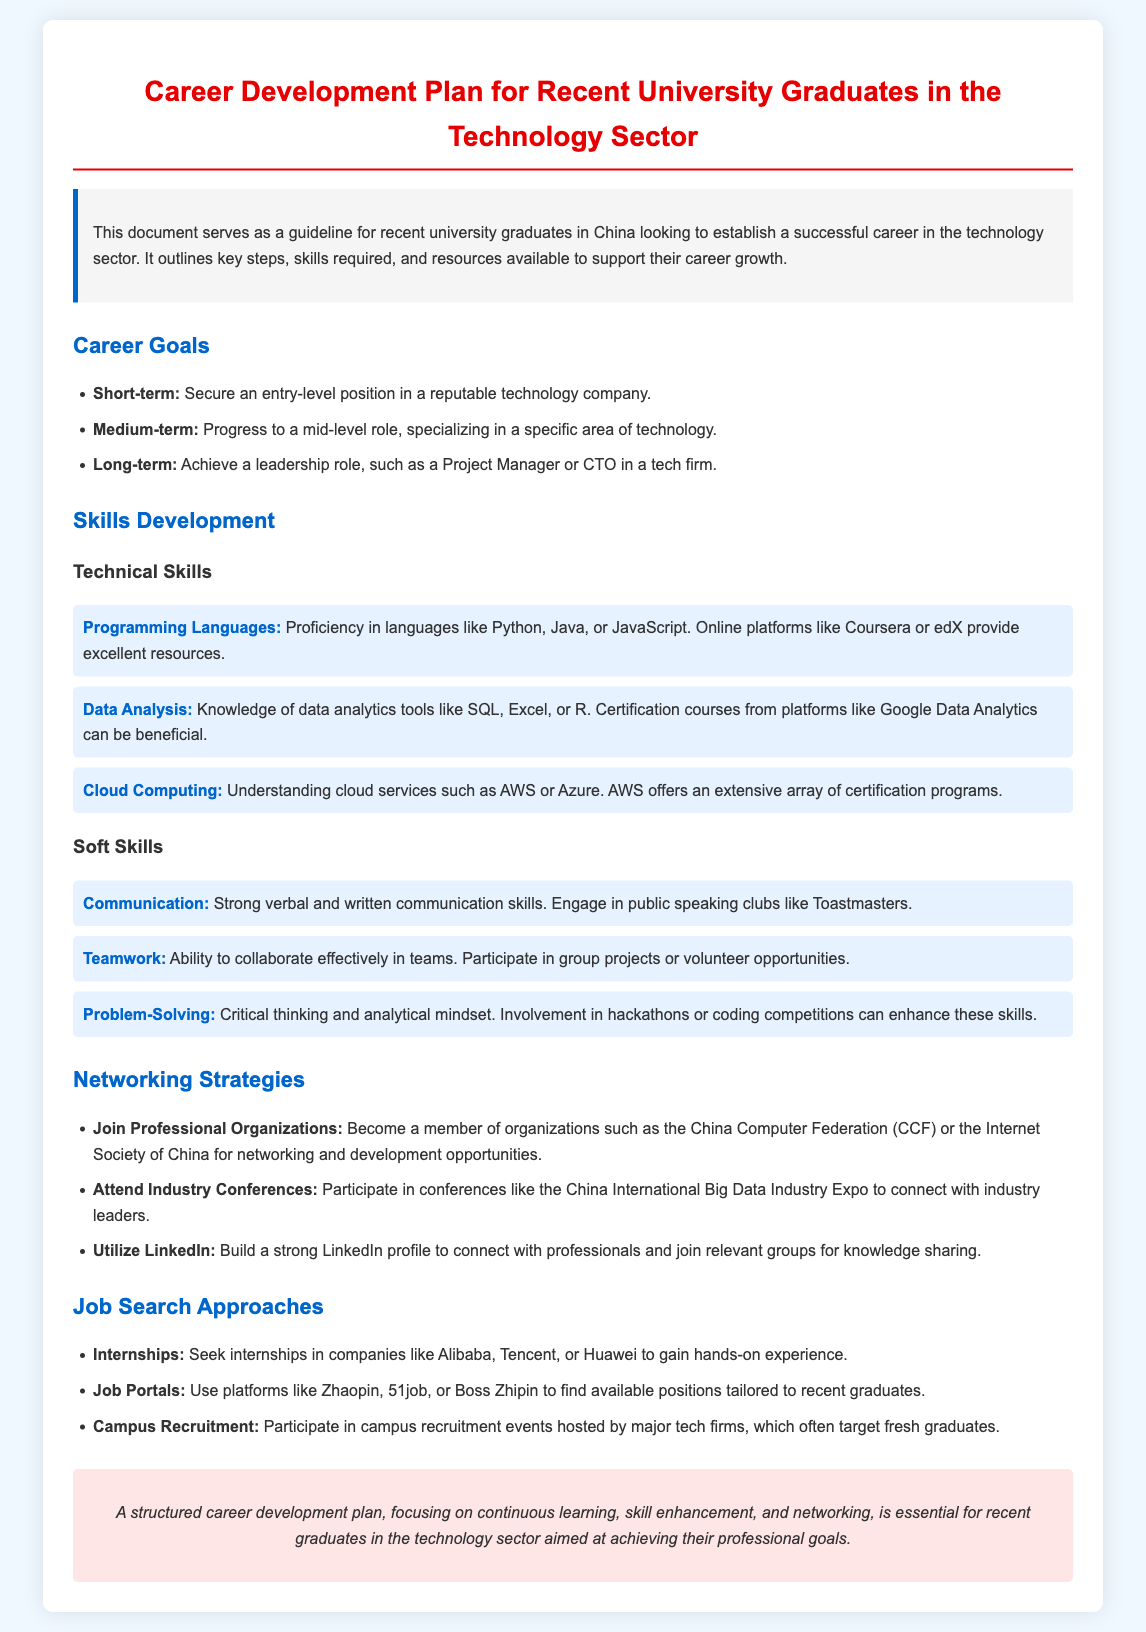What is the title of this document? The title is a key information element that summarizes the content of the document, which is to provide career development guidance for graduates in tech.
Answer: Career Development Plan for Recent University Graduates in the Technology Sector What is the short-term career goal mentioned? The short-term career goal is explicitly outlined in the goals section, focusing on entry-level employment.
Answer: Secure an entry-level position in a reputable technology company What technical skill is recommended for data analysis? The document lists technical skills, and for data analysis, it mentions specific tools essential for proficiency in the field.
Answer: SQL, Excel, or R Which organization is suggested for networking? The document mentions professional organizations that help with networking; one of which is highlighted as relevant for professionals in the tech sector.
Answer: China Computer Federation What is a recommended job search approach? The document specifies various strategies for searching for jobs, indicating practical ways graduates can find employment opportunities.
Answer: Internships What long-term career role is mentioned? The long-term career goal reflects aspirations within the technology sector, pointing towards leadership and management positions.
Answer: Project Manager or CTO Who should participate in campus recruitment events? The document specifies the target audience for campus recruitment events, ensuring they'll benefit graduates entering the workforce.
Answer: Fresh graduates What is an essential soft skill highlighted? The document emphasizes various soft skills necessary for success; one skill is singled out due to its importance in professional environments.
Answer: Communication 